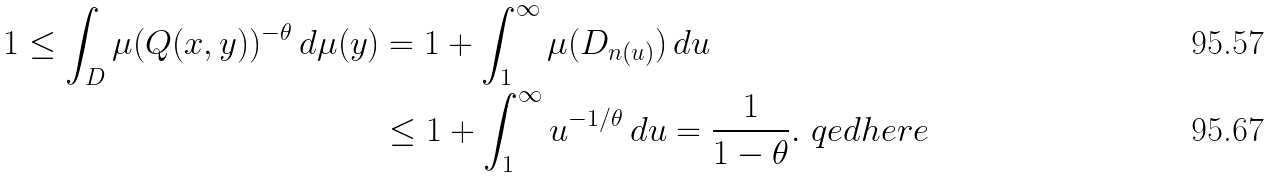<formula> <loc_0><loc_0><loc_500><loc_500>1 \leq \int _ { D } \mu ( Q ( x , y ) ) ^ { - \theta } \, d \mu ( y ) & = 1 + \int _ { 1 } ^ { \infty } \mu ( D _ { n ( u ) } ) \, d u \\ & \leq 1 + \int _ { 1 } ^ { \infty } u ^ { - 1 / \theta } \, d u = \frac { 1 } { 1 - \theta } . \ q e d h e r e</formula> 